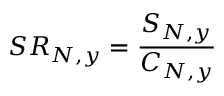<formula> <loc_0><loc_0><loc_500><loc_500>S R _ { N , y } = \frac { S _ { N , y } } { C _ { N , y } }</formula> 